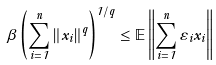<formula> <loc_0><loc_0><loc_500><loc_500>\beta \left ( \sum _ { i = 1 } ^ { n } \left \| x _ { i } \right \| ^ { q } \right ) ^ { 1 / q } \leq \mathbb { E } \left \| \sum _ { i = 1 } ^ { n } \varepsilon _ { i } x _ { i } \right \|</formula> 